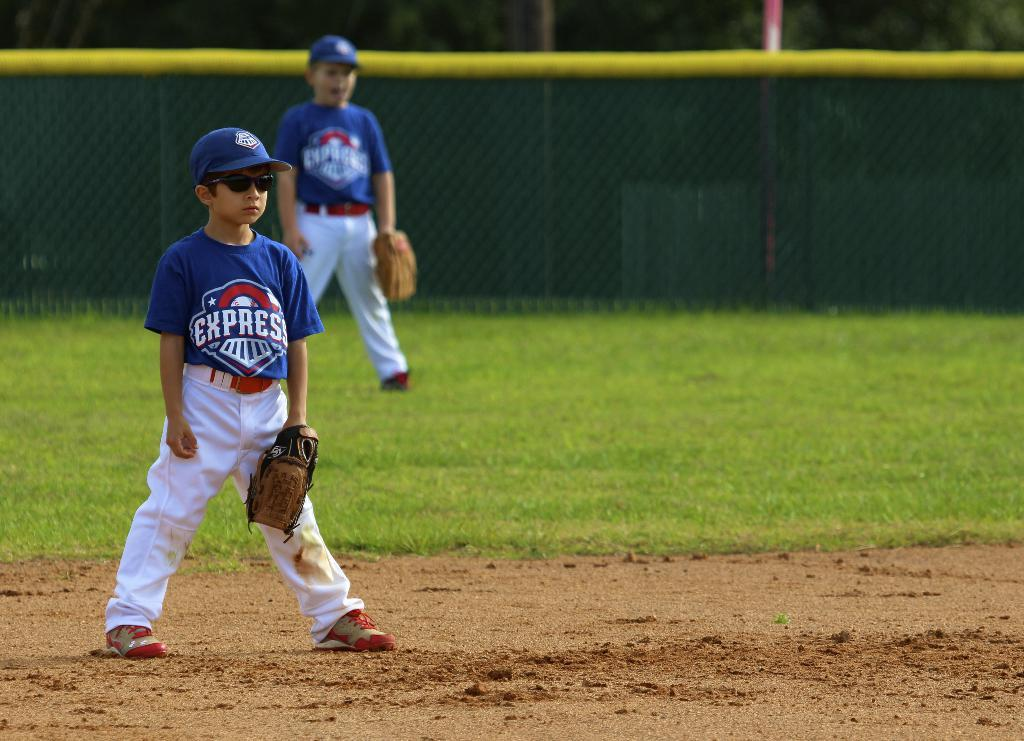Provide a one-sentence caption for the provided image. Baseball players for the Express team are on the field. 